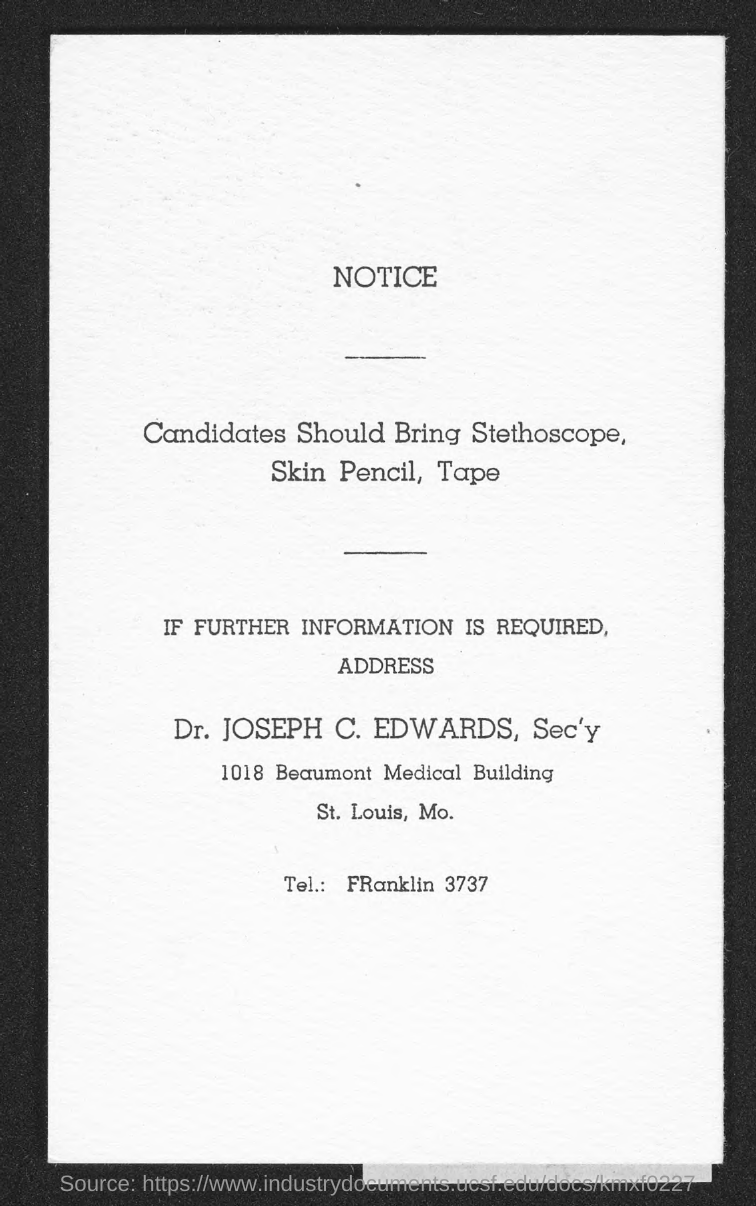What type of document is this?
Make the answer very short. NOTICE. IF FURTHER INFORMATION REQUIRED about Notice whom should be contacted?
Offer a terse response. Dr. JOSEPH C. EDWARDS. What is the designation of "Dr. JOSEPH C. EDWARDS"?
Make the answer very short. Sec'y. Provide "Tel" number of FRanklin?
Your answer should be compact. 3737. Mention "Beaumont Medical Building" number?
Your answer should be very brief. 1018. 